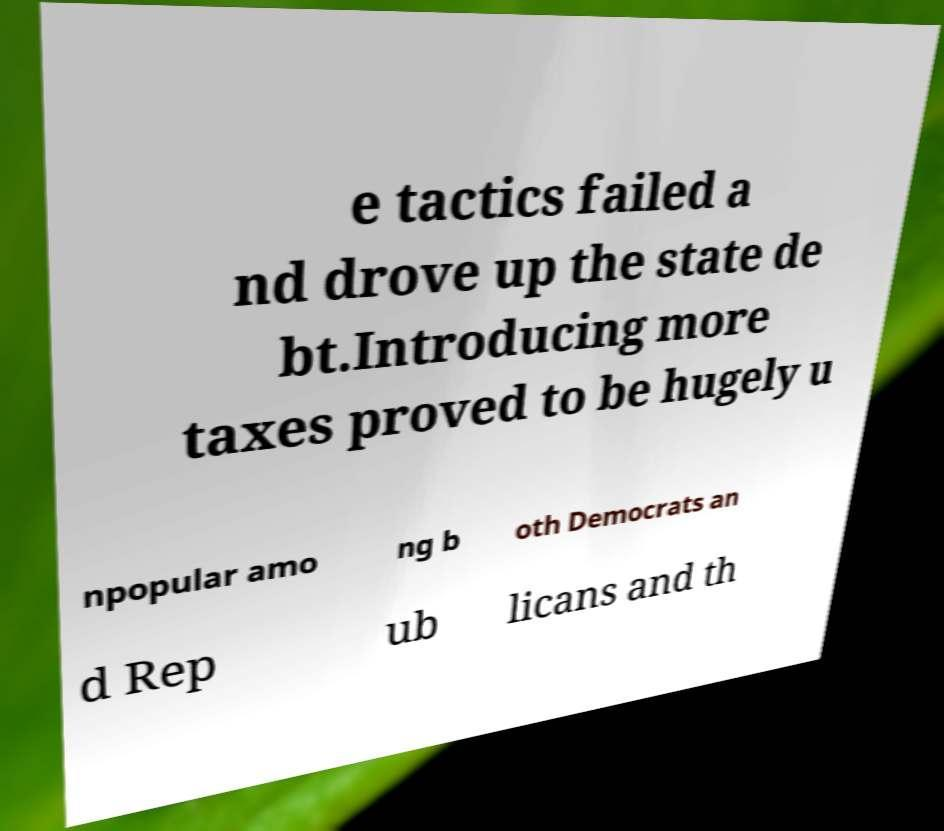Please identify and transcribe the text found in this image. e tactics failed a nd drove up the state de bt.Introducing more taxes proved to be hugely u npopular amo ng b oth Democrats an d Rep ub licans and th 